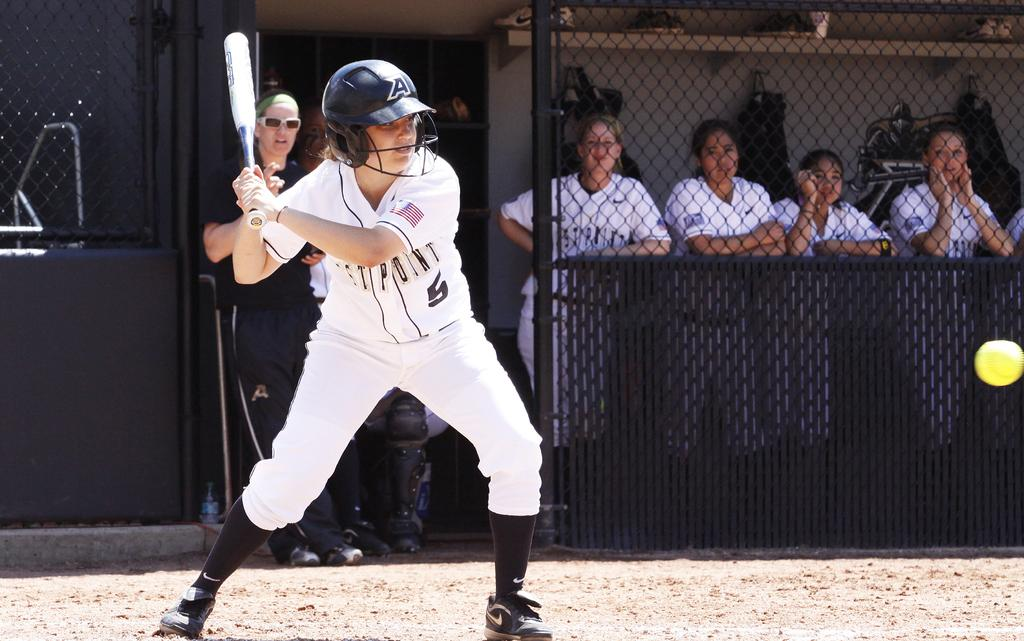<image>
Write a terse but informative summary of the picture. A baseball player with a West Point jersey on is about to swing at a pitch. 